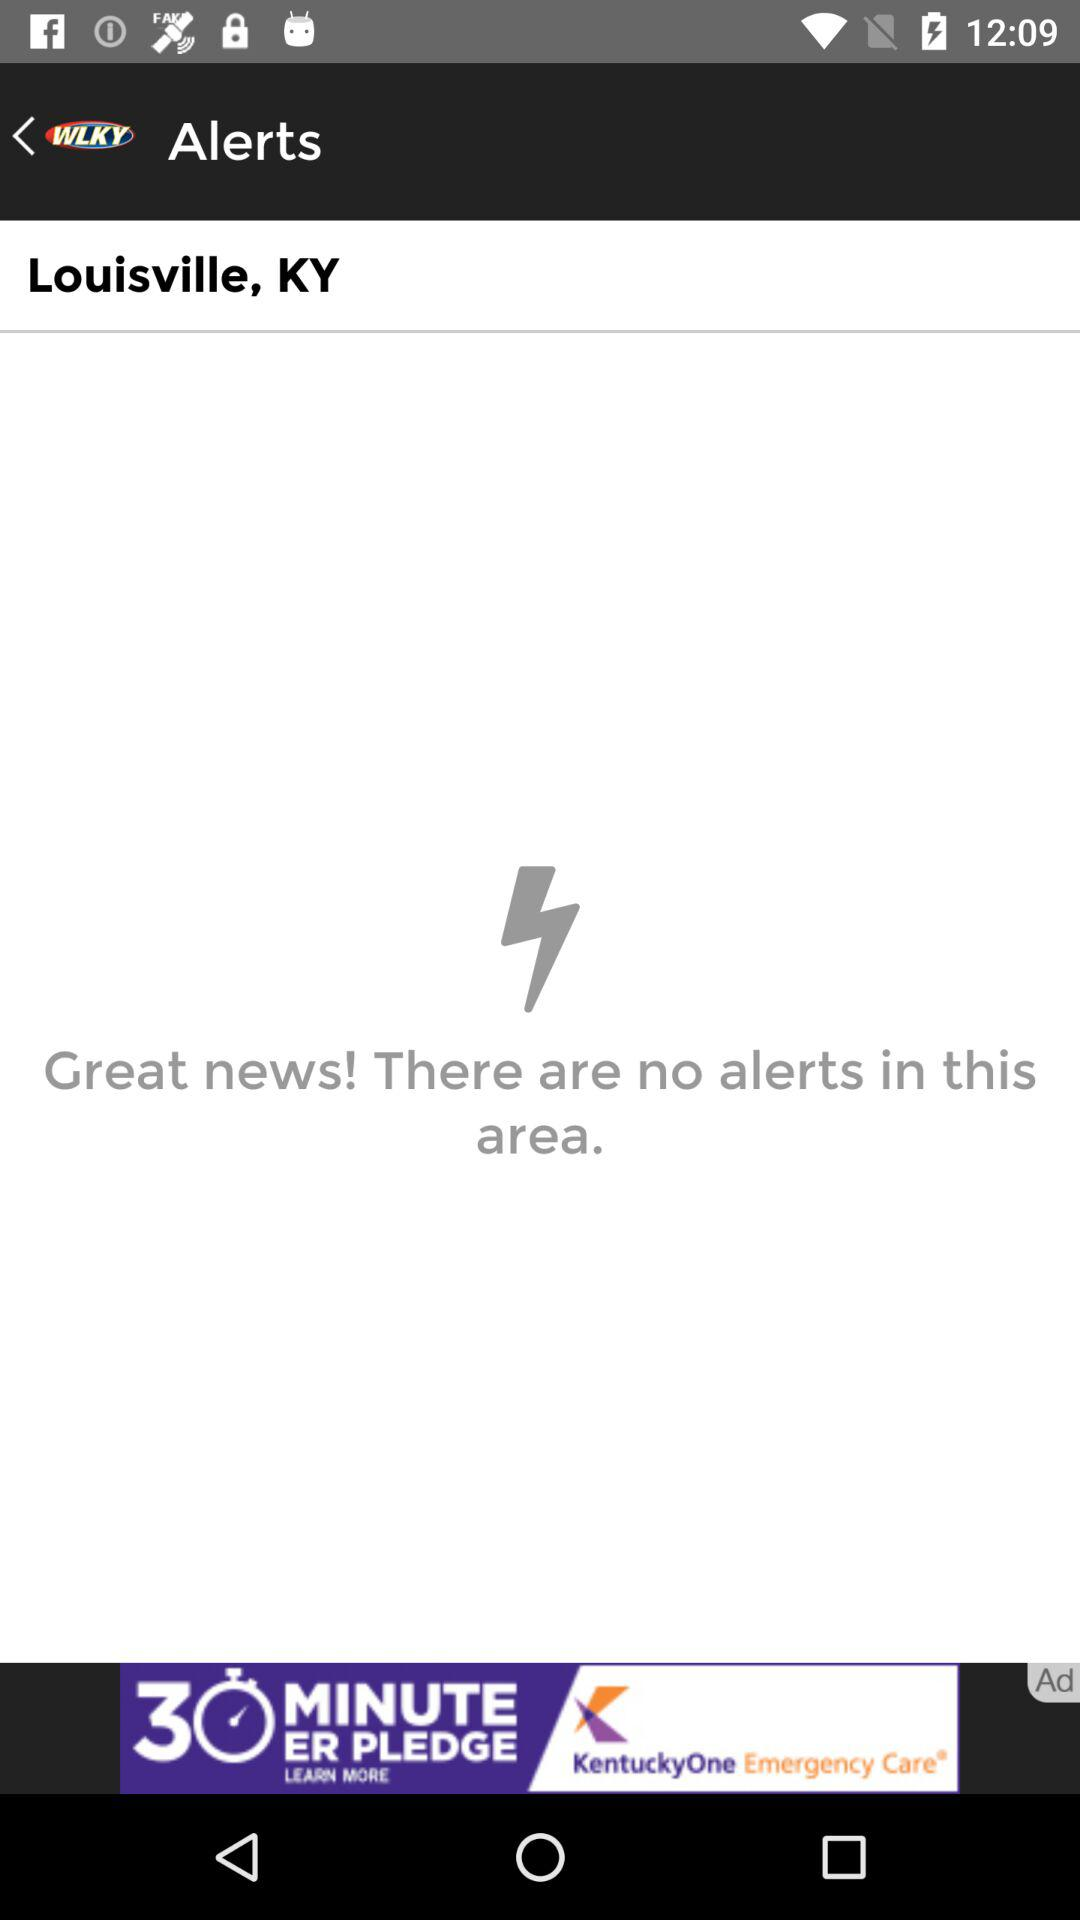Are there any alerts for Louisville? There are no alerts for Louisville. 